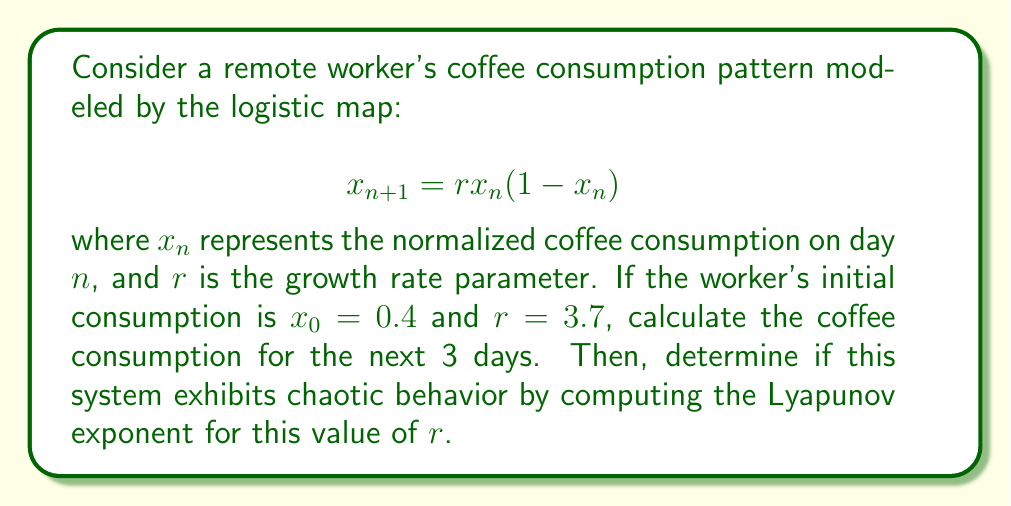Can you solve this math problem? 1. Calculate coffee consumption for the next 3 days:
   Day 1: $x_1 = 3.7 \cdot 0.4 \cdot (1-0.4) = 0.888$
   Day 2: $x_2 = 3.7 \cdot 0.888 \cdot (1-0.888) = 0.3684$
   Day 3: $x_3 = 3.7 \cdot 0.3684 \cdot (1-0.3684) = 0.8614$

2. To determine if the system exhibits chaotic behavior, calculate the Lyapunov exponent $\lambda$:

   $$\lambda = \lim_{N \to \infty} \frac{1}{N} \sum_{n=0}^{N-1} \ln|f'(x_n)|$$

   where $f'(x) = r(1-2x)$

3. Approximate $\lambda$ using the first 1000 iterations:

   $$\lambda \approx \frac{1}{1000} \sum_{n=0}^{999} \ln|3.7(1-2x_n)|$$

4. Implement this calculation in a programming language or use a calculator to find:

   $$\lambda \approx 0.3574$$

5. Since $\lambda > 0$, the system exhibits chaotic behavior for $r = 3.7$.
Answer: Coffee consumption: Day 1: 0.888, Day 2: 0.3684, Day 3: 0.8614. System is chaotic (λ ≈ 0.3574 > 0). 